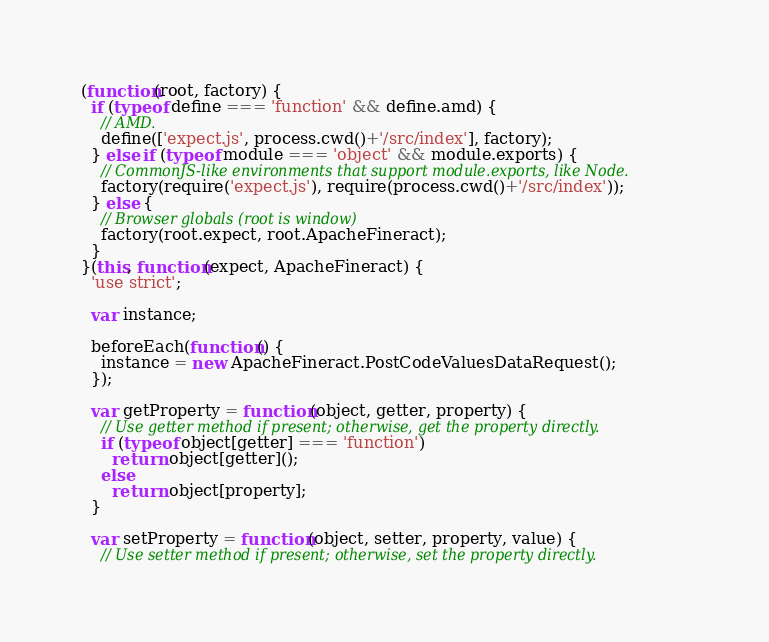<code> <loc_0><loc_0><loc_500><loc_500><_JavaScript_>

(function(root, factory) {
  if (typeof define === 'function' && define.amd) {
    // AMD.
    define(['expect.js', process.cwd()+'/src/index'], factory);
  } else if (typeof module === 'object' && module.exports) {
    // CommonJS-like environments that support module.exports, like Node.
    factory(require('expect.js'), require(process.cwd()+'/src/index'));
  } else {
    // Browser globals (root is window)
    factory(root.expect, root.ApacheFineract);
  }
}(this, function(expect, ApacheFineract) {
  'use strict';

  var instance;

  beforeEach(function() {
    instance = new ApacheFineract.PostCodeValuesDataRequest();
  });

  var getProperty = function(object, getter, property) {
    // Use getter method if present; otherwise, get the property directly.
    if (typeof object[getter] === 'function')
      return object[getter]();
    else
      return object[property];
  }

  var setProperty = function(object, setter, property, value) {
    // Use setter method if present; otherwise, set the property directly.</code> 